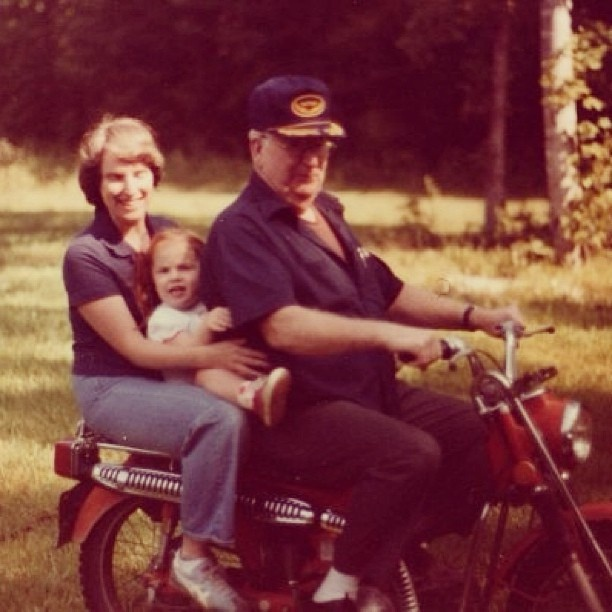Describe the objects in this image and their specific colors. I can see people in brown, maroon, purple, and tan tones, motorcycle in brown and maroon tones, people in brown, maroon, and purple tones, and people in brown, maroon, tan, and salmon tones in this image. 